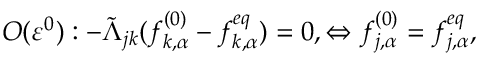<formula> <loc_0><loc_0><loc_500><loc_500>O ( \varepsilon ^ { 0 } ) \colon - \tilde { \Lambda } _ { j k } ( f _ { k , \alpha } ^ { ( 0 ) } - f _ { k , \alpha } ^ { e q } ) = 0 , \Leftrightarrow f _ { j , \alpha } ^ { ( 0 ) } = f _ { j , \alpha } ^ { e q } ,</formula> 